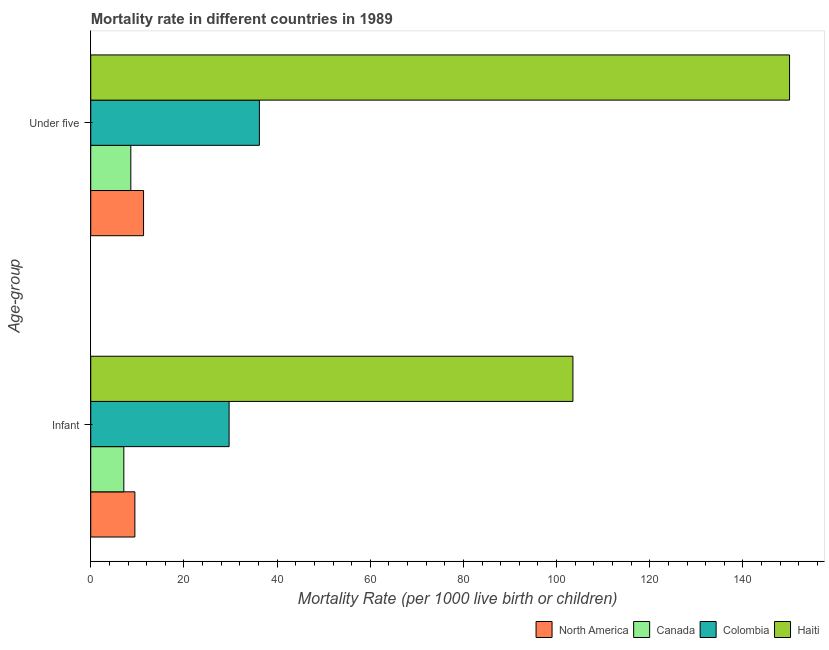How many different coloured bars are there?
Offer a terse response. 4. Are the number of bars per tick equal to the number of legend labels?
Make the answer very short. Yes. Are the number of bars on each tick of the Y-axis equal?
Your answer should be very brief. Yes. How many bars are there on the 1st tick from the bottom?
Give a very brief answer. 4. What is the label of the 2nd group of bars from the top?
Offer a very short reply. Infant. What is the infant mortality rate in Colombia?
Your answer should be compact. 29.7. Across all countries, what is the maximum infant mortality rate?
Your answer should be very brief. 103.5. Across all countries, what is the minimum infant mortality rate?
Provide a short and direct response. 7.1. In which country was the under-5 mortality rate maximum?
Keep it short and to the point. Haiti. What is the total under-5 mortality rate in the graph?
Your answer should be compact. 206.13. What is the difference between the under-5 mortality rate in Colombia and that in Haiti?
Give a very brief answer. -113.8. What is the difference between the infant mortality rate in Colombia and the under-5 mortality rate in North America?
Your response must be concise. 18.37. What is the average under-5 mortality rate per country?
Ensure brevity in your answer.  51.53. What is the difference between the under-5 mortality rate and infant mortality rate in Haiti?
Give a very brief answer. 46.5. What is the ratio of the infant mortality rate in Colombia to that in Canada?
Keep it short and to the point. 4.18. How many bars are there?
Offer a very short reply. 8. Are all the bars in the graph horizontal?
Provide a short and direct response. Yes. How many countries are there in the graph?
Your answer should be very brief. 4. What is the difference between two consecutive major ticks on the X-axis?
Your answer should be very brief. 20. Are the values on the major ticks of X-axis written in scientific E-notation?
Your answer should be very brief. No. Where does the legend appear in the graph?
Your answer should be compact. Bottom right. How many legend labels are there?
Provide a short and direct response. 4. How are the legend labels stacked?
Offer a very short reply. Horizontal. What is the title of the graph?
Your answer should be very brief. Mortality rate in different countries in 1989. Does "Eritrea" appear as one of the legend labels in the graph?
Your answer should be compact. No. What is the label or title of the X-axis?
Your response must be concise. Mortality Rate (per 1000 live birth or children). What is the label or title of the Y-axis?
Your answer should be compact. Age-group. What is the Mortality Rate (per 1000 live birth or children) of North America in Infant?
Provide a short and direct response. 9.47. What is the Mortality Rate (per 1000 live birth or children) of Colombia in Infant?
Provide a short and direct response. 29.7. What is the Mortality Rate (per 1000 live birth or children) in Haiti in Infant?
Provide a succinct answer. 103.5. What is the Mortality Rate (per 1000 live birth or children) in North America in Under five?
Ensure brevity in your answer.  11.33. What is the Mortality Rate (per 1000 live birth or children) in Colombia in Under five?
Give a very brief answer. 36.2. What is the Mortality Rate (per 1000 live birth or children) in Haiti in Under five?
Offer a terse response. 150. Across all Age-group, what is the maximum Mortality Rate (per 1000 live birth or children) of North America?
Offer a very short reply. 11.33. Across all Age-group, what is the maximum Mortality Rate (per 1000 live birth or children) in Canada?
Your response must be concise. 8.6. Across all Age-group, what is the maximum Mortality Rate (per 1000 live birth or children) in Colombia?
Your answer should be compact. 36.2. Across all Age-group, what is the maximum Mortality Rate (per 1000 live birth or children) in Haiti?
Give a very brief answer. 150. Across all Age-group, what is the minimum Mortality Rate (per 1000 live birth or children) in North America?
Keep it short and to the point. 9.47. Across all Age-group, what is the minimum Mortality Rate (per 1000 live birth or children) of Canada?
Offer a terse response. 7.1. Across all Age-group, what is the minimum Mortality Rate (per 1000 live birth or children) in Colombia?
Offer a terse response. 29.7. Across all Age-group, what is the minimum Mortality Rate (per 1000 live birth or children) of Haiti?
Your answer should be compact. 103.5. What is the total Mortality Rate (per 1000 live birth or children) in North America in the graph?
Your answer should be compact. 20.8. What is the total Mortality Rate (per 1000 live birth or children) in Colombia in the graph?
Make the answer very short. 65.9. What is the total Mortality Rate (per 1000 live birth or children) of Haiti in the graph?
Keep it short and to the point. 253.5. What is the difference between the Mortality Rate (per 1000 live birth or children) of North America in Infant and that in Under five?
Offer a very short reply. -1.86. What is the difference between the Mortality Rate (per 1000 live birth or children) in Colombia in Infant and that in Under five?
Provide a succinct answer. -6.5. What is the difference between the Mortality Rate (per 1000 live birth or children) of Haiti in Infant and that in Under five?
Your response must be concise. -46.5. What is the difference between the Mortality Rate (per 1000 live birth or children) in North America in Infant and the Mortality Rate (per 1000 live birth or children) in Canada in Under five?
Offer a very short reply. 0.87. What is the difference between the Mortality Rate (per 1000 live birth or children) in North America in Infant and the Mortality Rate (per 1000 live birth or children) in Colombia in Under five?
Your answer should be very brief. -26.73. What is the difference between the Mortality Rate (per 1000 live birth or children) in North America in Infant and the Mortality Rate (per 1000 live birth or children) in Haiti in Under five?
Provide a short and direct response. -140.53. What is the difference between the Mortality Rate (per 1000 live birth or children) in Canada in Infant and the Mortality Rate (per 1000 live birth or children) in Colombia in Under five?
Your answer should be compact. -29.1. What is the difference between the Mortality Rate (per 1000 live birth or children) in Canada in Infant and the Mortality Rate (per 1000 live birth or children) in Haiti in Under five?
Make the answer very short. -142.9. What is the difference between the Mortality Rate (per 1000 live birth or children) in Colombia in Infant and the Mortality Rate (per 1000 live birth or children) in Haiti in Under five?
Keep it short and to the point. -120.3. What is the average Mortality Rate (per 1000 live birth or children) of North America per Age-group?
Ensure brevity in your answer.  10.4. What is the average Mortality Rate (per 1000 live birth or children) in Canada per Age-group?
Provide a short and direct response. 7.85. What is the average Mortality Rate (per 1000 live birth or children) in Colombia per Age-group?
Offer a very short reply. 32.95. What is the average Mortality Rate (per 1000 live birth or children) of Haiti per Age-group?
Your answer should be compact. 126.75. What is the difference between the Mortality Rate (per 1000 live birth or children) of North America and Mortality Rate (per 1000 live birth or children) of Canada in Infant?
Your answer should be compact. 2.37. What is the difference between the Mortality Rate (per 1000 live birth or children) of North America and Mortality Rate (per 1000 live birth or children) of Colombia in Infant?
Your response must be concise. -20.23. What is the difference between the Mortality Rate (per 1000 live birth or children) in North America and Mortality Rate (per 1000 live birth or children) in Haiti in Infant?
Make the answer very short. -94.03. What is the difference between the Mortality Rate (per 1000 live birth or children) in Canada and Mortality Rate (per 1000 live birth or children) in Colombia in Infant?
Ensure brevity in your answer.  -22.6. What is the difference between the Mortality Rate (per 1000 live birth or children) in Canada and Mortality Rate (per 1000 live birth or children) in Haiti in Infant?
Make the answer very short. -96.4. What is the difference between the Mortality Rate (per 1000 live birth or children) in Colombia and Mortality Rate (per 1000 live birth or children) in Haiti in Infant?
Offer a terse response. -73.8. What is the difference between the Mortality Rate (per 1000 live birth or children) of North America and Mortality Rate (per 1000 live birth or children) of Canada in Under five?
Provide a short and direct response. 2.73. What is the difference between the Mortality Rate (per 1000 live birth or children) in North America and Mortality Rate (per 1000 live birth or children) in Colombia in Under five?
Keep it short and to the point. -24.87. What is the difference between the Mortality Rate (per 1000 live birth or children) in North America and Mortality Rate (per 1000 live birth or children) in Haiti in Under five?
Keep it short and to the point. -138.67. What is the difference between the Mortality Rate (per 1000 live birth or children) of Canada and Mortality Rate (per 1000 live birth or children) of Colombia in Under five?
Ensure brevity in your answer.  -27.6. What is the difference between the Mortality Rate (per 1000 live birth or children) in Canada and Mortality Rate (per 1000 live birth or children) in Haiti in Under five?
Your response must be concise. -141.4. What is the difference between the Mortality Rate (per 1000 live birth or children) in Colombia and Mortality Rate (per 1000 live birth or children) in Haiti in Under five?
Offer a very short reply. -113.8. What is the ratio of the Mortality Rate (per 1000 live birth or children) of North America in Infant to that in Under five?
Make the answer very short. 0.84. What is the ratio of the Mortality Rate (per 1000 live birth or children) in Canada in Infant to that in Under five?
Your answer should be very brief. 0.83. What is the ratio of the Mortality Rate (per 1000 live birth or children) in Colombia in Infant to that in Under five?
Provide a short and direct response. 0.82. What is the ratio of the Mortality Rate (per 1000 live birth or children) of Haiti in Infant to that in Under five?
Offer a terse response. 0.69. What is the difference between the highest and the second highest Mortality Rate (per 1000 live birth or children) in North America?
Keep it short and to the point. 1.86. What is the difference between the highest and the second highest Mortality Rate (per 1000 live birth or children) of Haiti?
Provide a short and direct response. 46.5. What is the difference between the highest and the lowest Mortality Rate (per 1000 live birth or children) of North America?
Your answer should be compact. 1.86. What is the difference between the highest and the lowest Mortality Rate (per 1000 live birth or children) in Canada?
Your answer should be compact. 1.5. What is the difference between the highest and the lowest Mortality Rate (per 1000 live birth or children) of Colombia?
Offer a terse response. 6.5. What is the difference between the highest and the lowest Mortality Rate (per 1000 live birth or children) in Haiti?
Your answer should be compact. 46.5. 